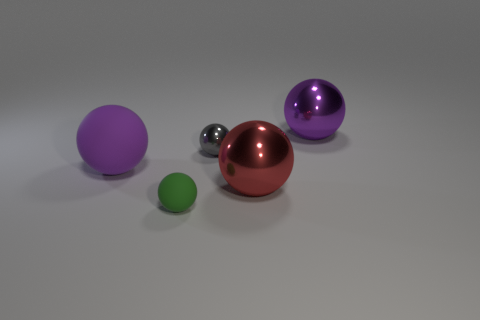Add 3 big purple metal things. How many objects exist? 8 Subtract all metal balls. How many balls are left? 2 Subtract all blue cubes. How many purple spheres are left? 2 Subtract all red balls. How many balls are left? 4 Subtract all brown balls. Subtract all cyan cylinders. How many balls are left? 5 Subtract all cyan rubber cylinders. Subtract all big purple rubber spheres. How many objects are left? 4 Add 1 large red metallic objects. How many large red metallic objects are left? 2 Add 4 large shiny spheres. How many large shiny spheres exist? 6 Subtract 1 green balls. How many objects are left? 4 